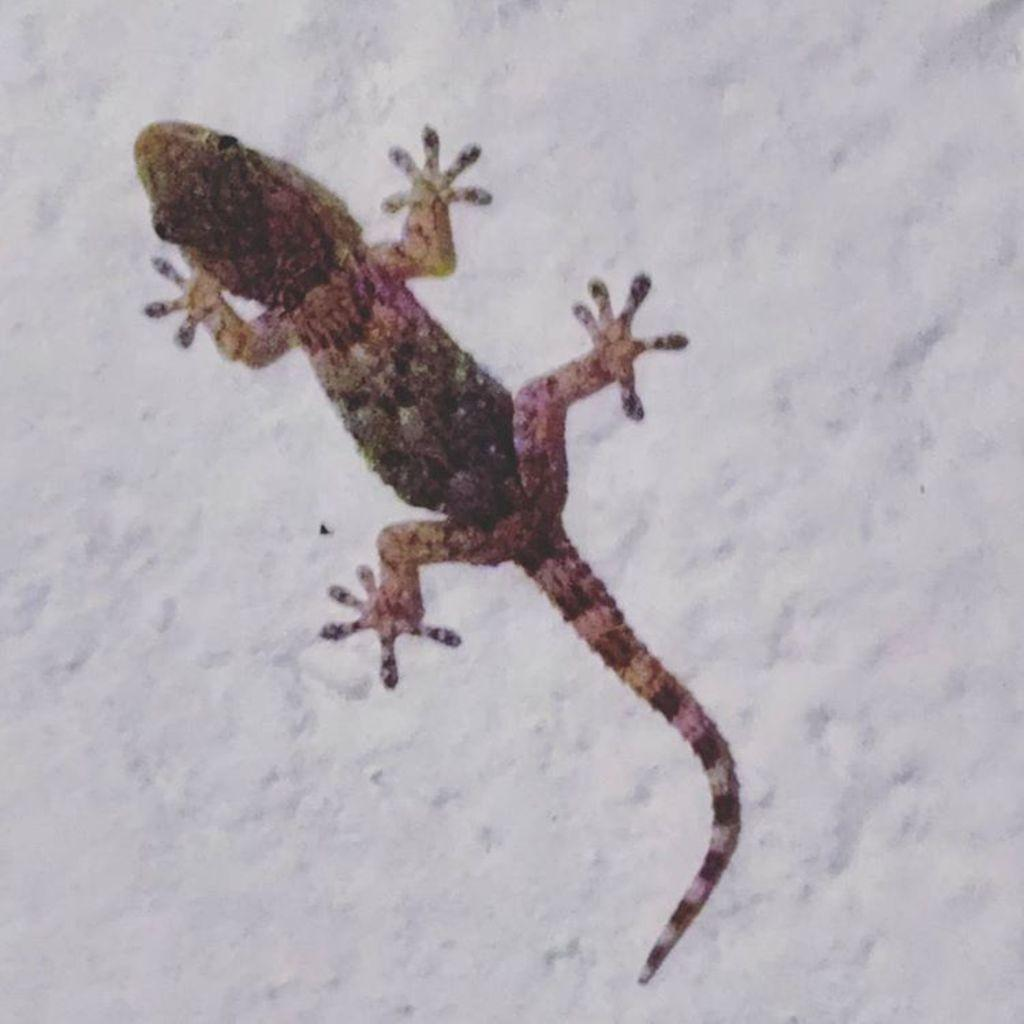What type of animal is in the image? There is a lizard in the image. What colors can be seen on the lizard? The lizard is black, pink, and green in color. Where is the lizard located in the image? The lizard is on a white-colored wall. How does the lizard pull the mint leaves in the image? There are no mint leaves present in the image, and the lizard is not shown pulling anything. 